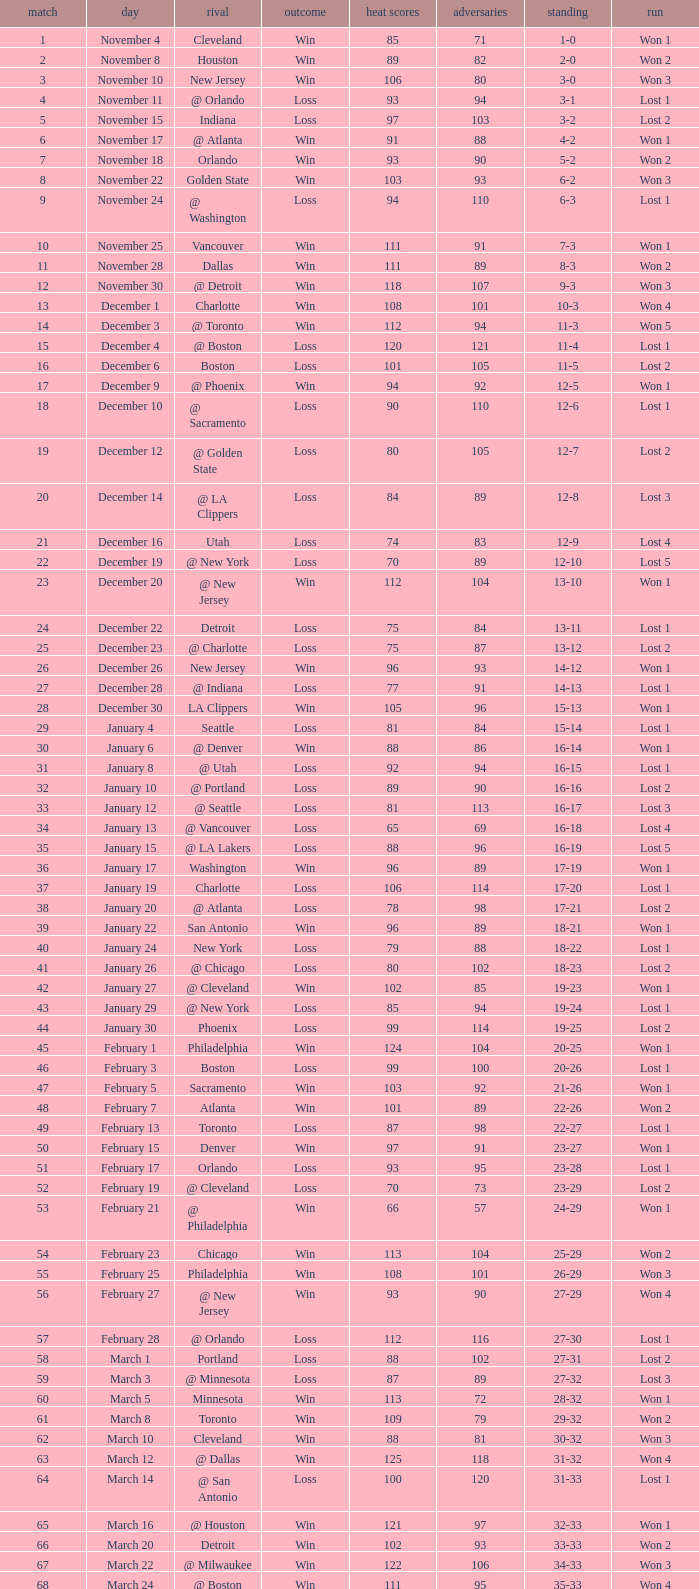What is Result, when Date is "December 12"? Loss. 